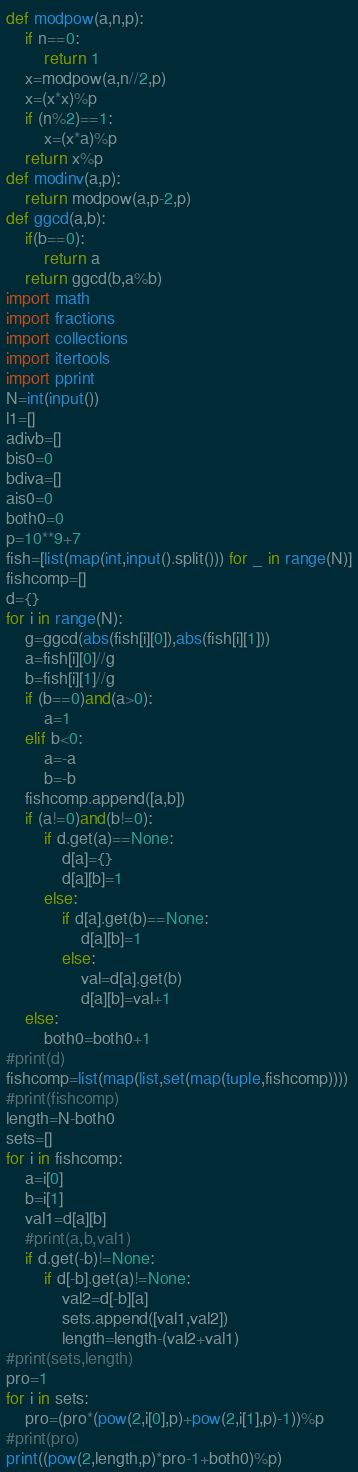Convert code to text. <code><loc_0><loc_0><loc_500><loc_500><_Python_>def modpow(a,n,p):
    if n==0:
        return 1
    x=modpow(a,n//2,p)
    x=(x*x)%p
    if (n%2)==1:
        x=(x*a)%p
    return x%p
def modinv(a,p):
    return modpow(a,p-2,p)
def ggcd(a,b):
    if(b==0):
        return a
    return ggcd(b,a%b)
import math
import fractions
import collections
import itertools
import pprint
N=int(input())
l1=[]
adivb=[]
bis0=0
bdiva=[]
ais0=0
both0=0
p=10**9+7
fish=[list(map(int,input().split())) for _ in range(N)]
fishcomp=[]
d={}
for i in range(N):
    g=ggcd(abs(fish[i][0]),abs(fish[i][1]))
    a=fish[i][0]//g
    b=fish[i][1]//g
    if (b==0)and(a>0):
        a=1
    elif b<0:
        a=-a
        b=-b
    fishcomp.append([a,b])
    if (a!=0)and(b!=0):
        if d.get(a)==None:
            d[a]={}
            d[a][b]=1
        else:
            if d[a].get(b)==None:
                d[a][b]=1
            else:
                val=d[a].get(b)
                d[a][b]=val+1
    else:
        both0=both0+1
#print(d)
fishcomp=list(map(list,set(map(tuple,fishcomp))))
#print(fishcomp)
length=N-both0
sets=[]
for i in fishcomp:
    a=i[0]
    b=i[1]
    val1=d[a][b]
    #print(a,b,val1)
    if d.get(-b)!=None:
        if d[-b].get(a)!=None:
            val2=d[-b][a]
            sets.append([val1,val2])
            length=length-(val2+val1)
#print(sets,length)
pro=1
for i in sets:
    pro=(pro*(pow(2,i[0],p)+pow(2,i[1],p)-1))%p
#print(pro)
print((pow(2,length,p)*pro-1+both0)%p)</code> 